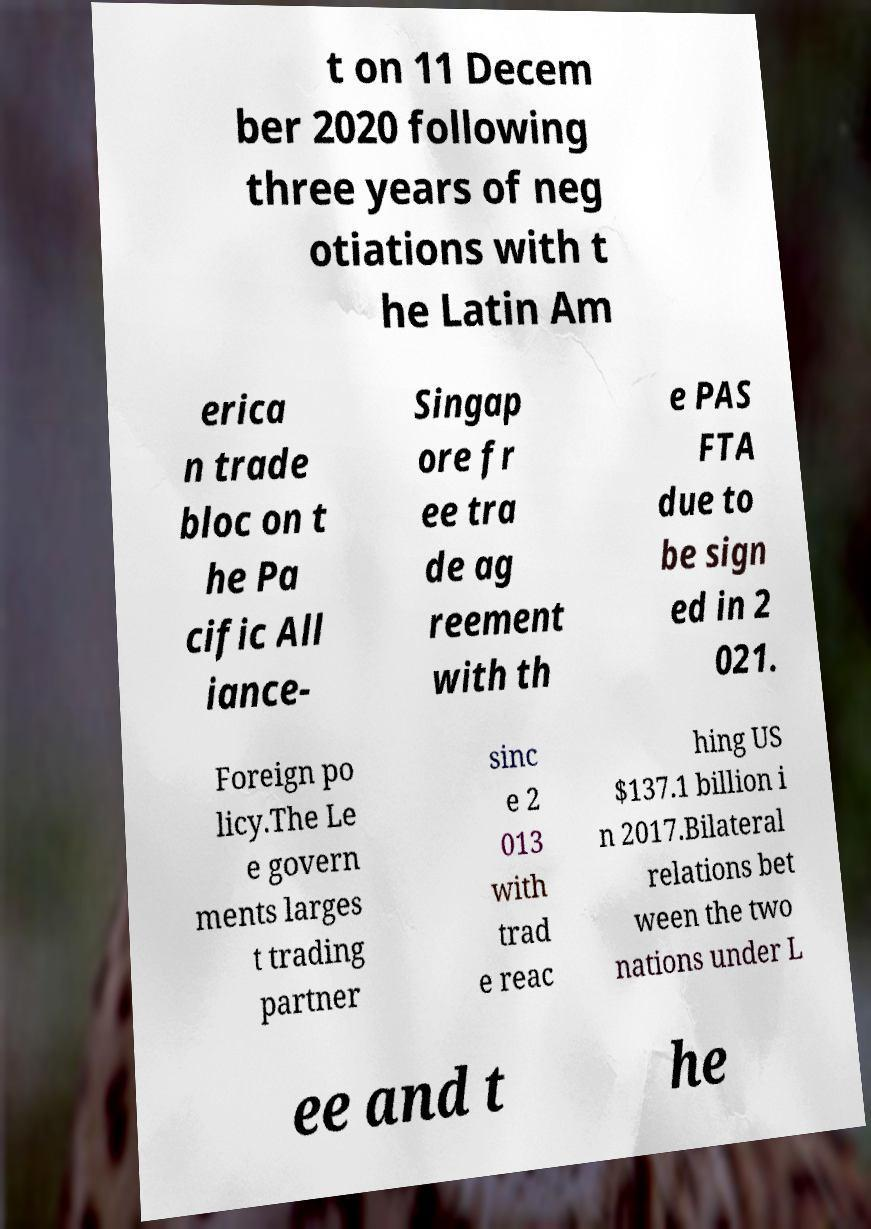Can you read and provide the text displayed in the image?This photo seems to have some interesting text. Can you extract and type it out for me? t on 11 Decem ber 2020 following three years of neg otiations with t he Latin Am erica n trade bloc on t he Pa cific All iance- Singap ore fr ee tra de ag reement with th e PAS FTA due to be sign ed in 2 021. Foreign po licy.The Le e govern ments larges t trading partner sinc e 2 013 with trad e reac hing US $137.1 billion i n 2017.Bilateral relations bet ween the two nations under L ee and t he 